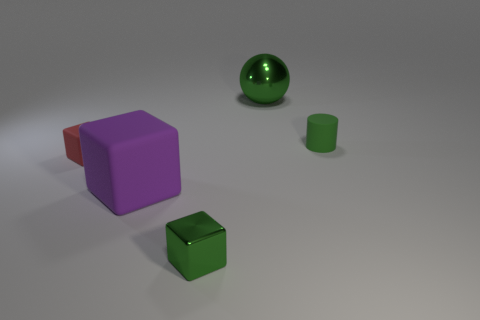Does the big object to the right of the tiny metal object have the same shape as the large purple matte object?
Your answer should be very brief. No. What number of other things are the same shape as the tiny green metallic thing?
Your answer should be very brief. 2. There is a big object that is left of the small green metal thing; what is its shape?
Offer a terse response. Cube. Are there any green blocks that have the same material as the cylinder?
Offer a terse response. No. There is a small rubber thing that is to the left of the green ball; does it have the same color as the rubber cylinder?
Make the answer very short. No. The green cube is what size?
Your answer should be compact. Small. Are there any large green metal things in front of the small green object that is in front of the large object in front of the rubber cylinder?
Offer a very short reply. No. There is a matte cylinder; how many tiny green cubes are on the left side of it?
Provide a succinct answer. 1. How many cylinders are the same color as the small metallic cube?
Keep it short and to the point. 1. What number of things are metal objects that are in front of the red matte object or tiny green things left of the green rubber cylinder?
Offer a terse response. 1. 